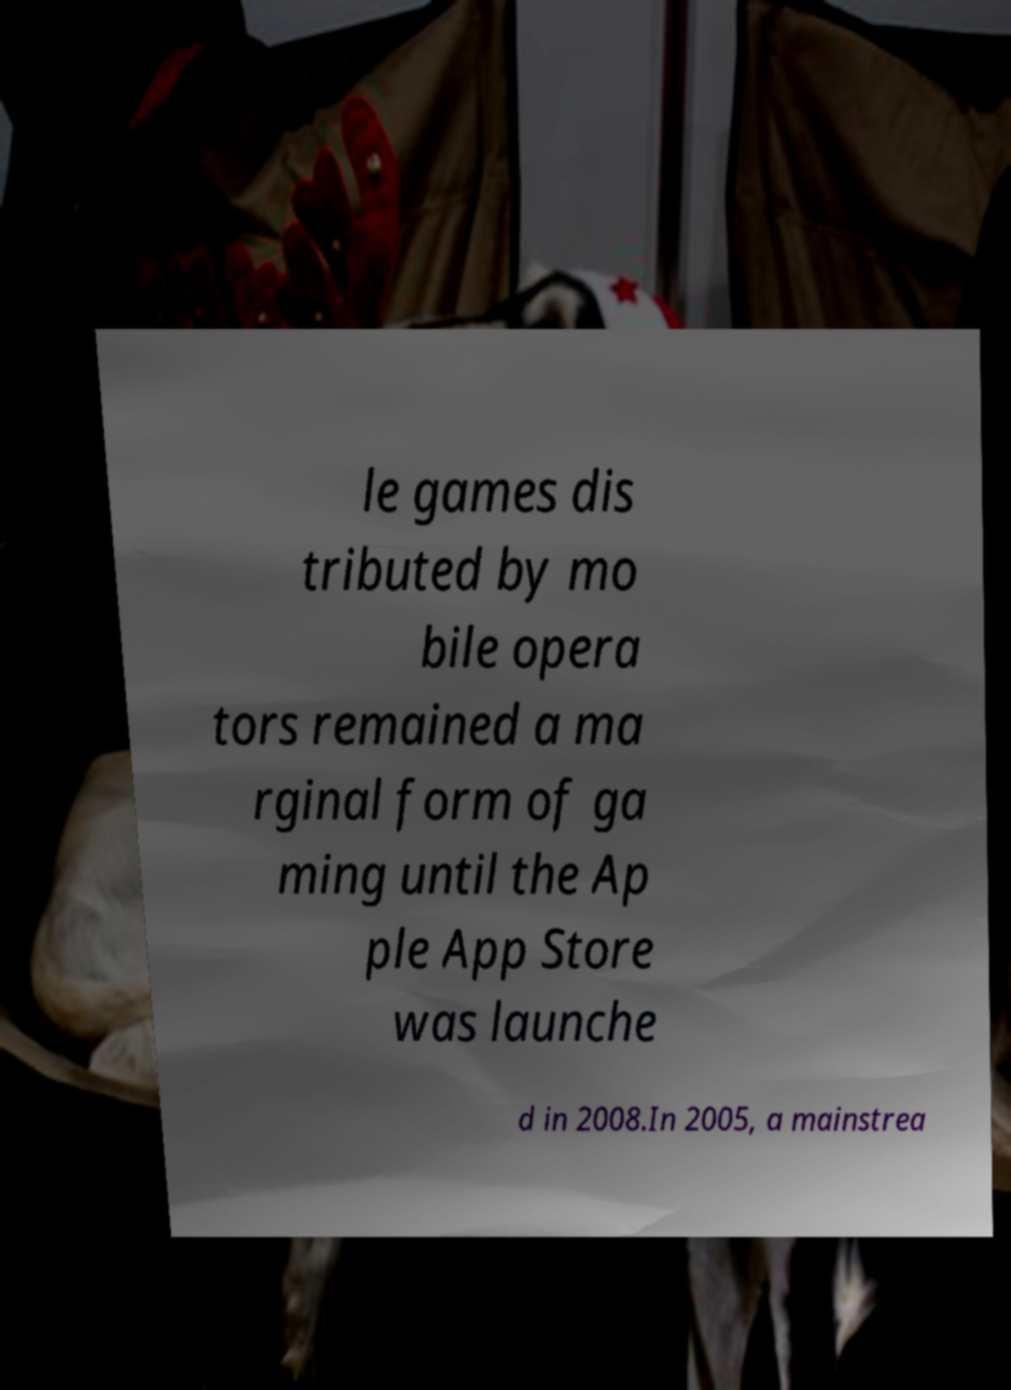Can you accurately transcribe the text from the provided image for me? le games dis tributed by mo bile opera tors remained a ma rginal form of ga ming until the Ap ple App Store was launche d in 2008.In 2005, a mainstrea 